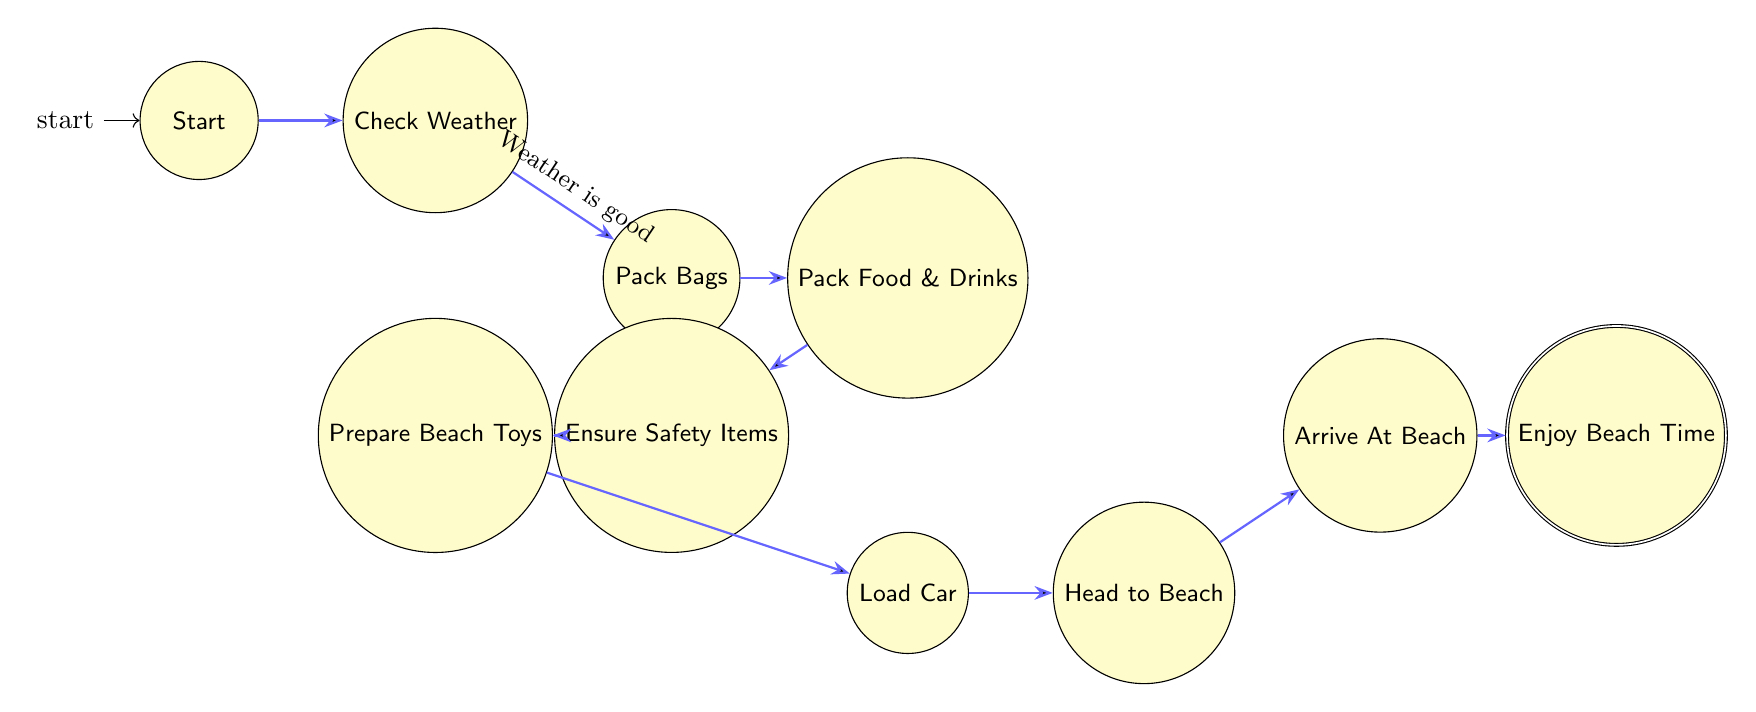What is the first state in the diagram? The diagram starts with the node labeled "Start," indicating the beginning of the beach outing preparation.
Answer: Start How many total nodes are in the diagram? Counting each individual state from "Start" to "Enjoy Beach Time," there are a total of 10 states (nodes) in the diagram.
Answer: 10 What is the last state before enjoying beach time? The last state before arriving at the "Enjoy Beach Time" state is "Arrive At Beach," which precedes the enjoyment phase.
Answer: Arrive At Beach Which state involves checking the weather? The state where checking the weather occurs is labeled "Check Weather," which is the second node in the sequence of preparations.
Answer: Check Weather What is the condition for transitioning from "Check Weather" to "Pack Bags"? The transition from "Check Weather" to "Pack Bags" occurs under the condition that "Weather is good." This means if the weather is unfavorable, one may not proceed further.
Answer: Weather is good How many transitions are there in the diagram? By examining the arrows connecting the states, there are 9 transitions leading from one state to the next in the preparation process.
Answer: 9 What do you do after ensuring safety items? After ensuring safety items are packed, the next state is "Prepare Beach Toys," which involves gathering and packing beach toys and activities.
Answer: Prepare Beach Toys Which state directly follows "Load Car"? The state that directly follows "Load Car" is labeled "Head to Beach," indicating the next step in the preparation process involves driving to the beach.
Answer: Head to Beach What is the significance of the "Enjoy Beach Time" state? The "Enjoy Beach Time" state signifies the completion of all preparations and the beginning of relaxation and fun at the beach with family.
Answer: Enjoy Beach Time 